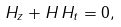<formula> <loc_0><loc_0><loc_500><loc_500>H _ { z } + H \, H _ { t } = 0 ,</formula> 